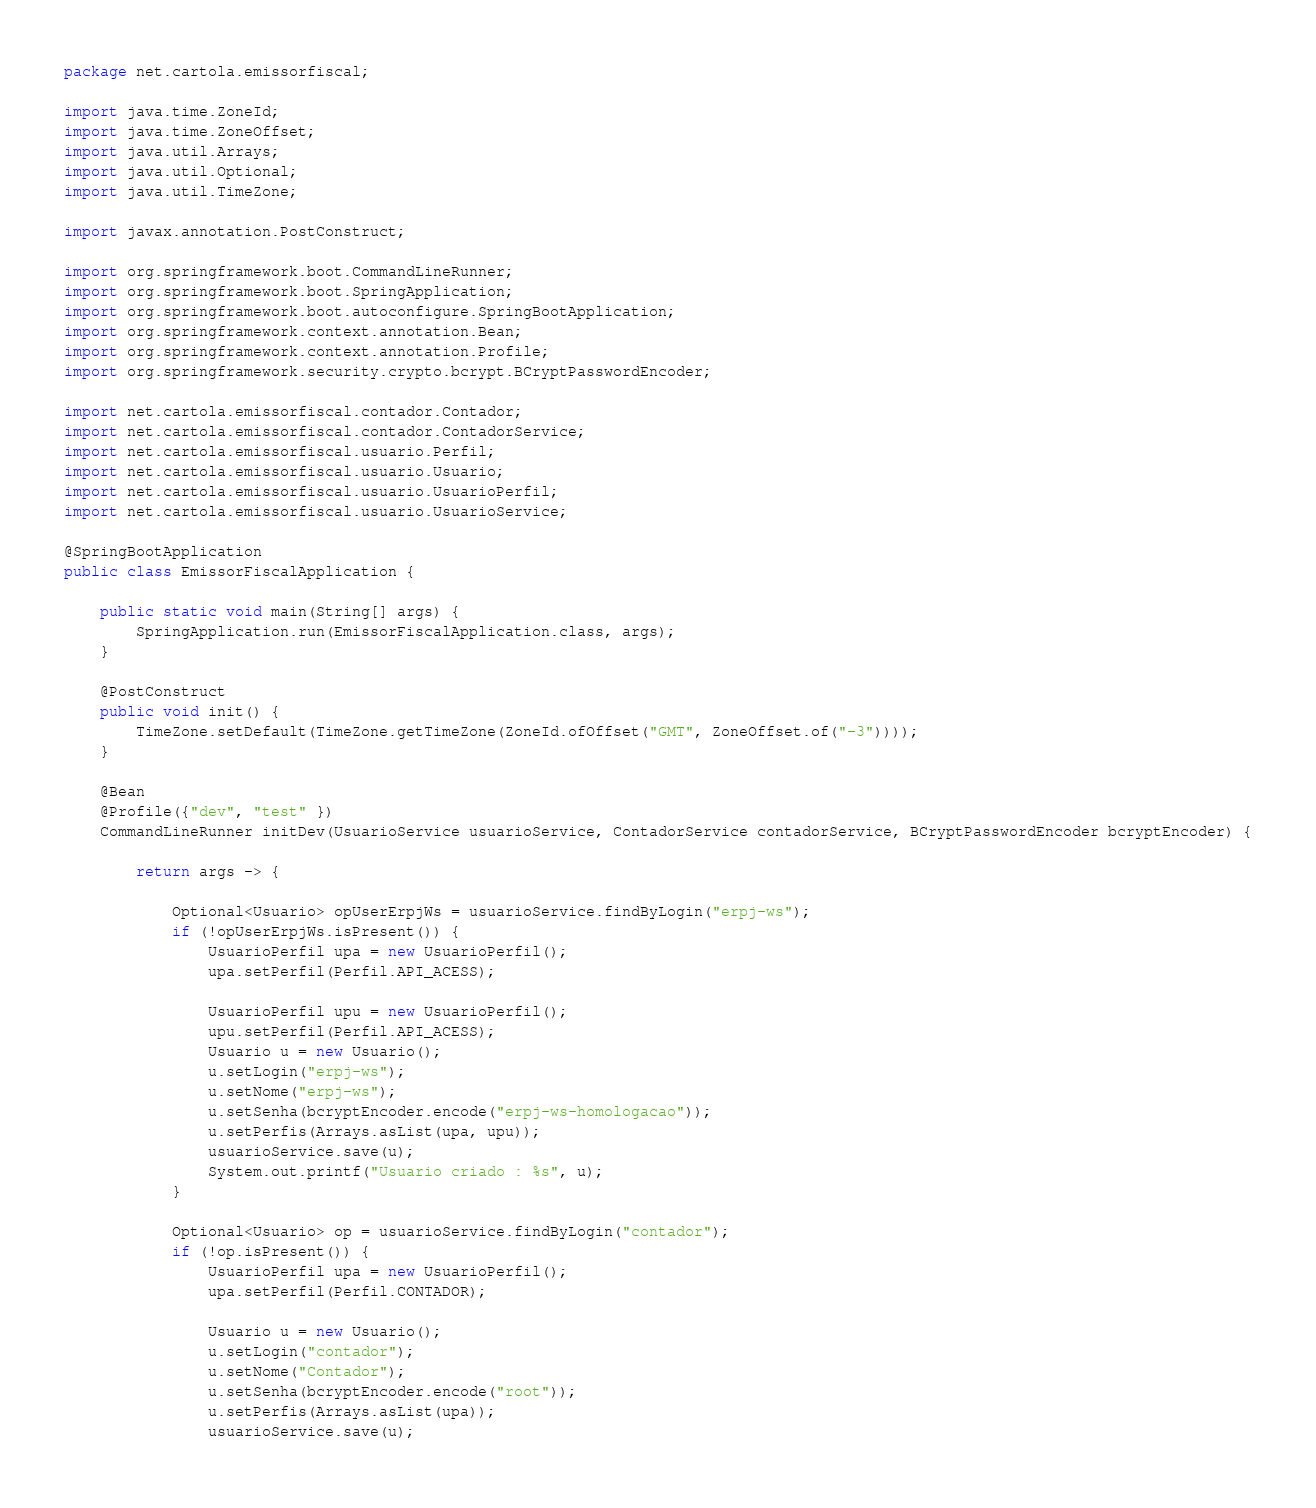Convert code to text. <code><loc_0><loc_0><loc_500><loc_500><_Java_>package net.cartola.emissorfiscal;

import java.time.ZoneId;
import java.time.ZoneOffset;
import java.util.Arrays;
import java.util.Optional;
import java.util.TimeZone;

import javax.annotation.PostConstruct;

import org.springframework.boot.CommandLineRunner;
import org.springframework.boot.SpringApplication;
import org.springframework.boot.autoconfigure.SpringBootApplication;
import org.springframework.context.annotation.Bean;
import org.springframework.context.annotation.Profile;
import org.springframework.security.crypto.bcrypt.BCryptPasswordEncoder;

import net.cartola.emissorfiscal.contador.Contador;
import net.cartola.emissorfiscal.contador.ContadorService;
import net.cartola.emissorfiscal.usuario.Perfil;
import net.cartola.emissorfiscal.usuario.Usuario;
import net.cartola.emissorfiscal.usuario.UsuarioPerfil;
import net.cartola.emissorfiscal.usuario.UsuarioService;

@SpringBootApplication
public class EmissorFiscalApplication {

	public static void main(String[] args) {
		SpringApplication.run(EmissorFiscalApplication.class, args);
	}
	
	@PostConstruct
	public void init() {
		TimeZone.setDefault(TimeZone.getTimeZone(ZoneId.ofOffset("GMT", ZoneOffset.of("-3"))));
	}
	
	@Bean
	@Profile({"dev", "test" })
	CommandLineRunner initDev(UsuarioService usuarioService, ContadorService contadorService, BCryptPasswordEncoder bcryptEncoder) {

		return args -> {
			
			Optional<Usuario> opUserErpjWs = usuarioService.findByLogin("erpj-ws");
			if (!opUserErpjWs.isPresent()) {
				UsuarioPerfil upa = new UsuarioPerfil();
				upa.setPerfil(Perfil.API_ACESS);

				UsuarioPerfil upu = new UsuarioPerfil();
				upu.setPerfil(Perfil.API_ACESS);
				Usuario u = new Usuario();
				u.setLogin("erpj-ws");
				u.setNome("erpj-ws");
				u.setSenha(bcryptEncoder.encode("erpj-ws-homologacao")); 
				u.setPerfis(Arrays.asList(upa, upu)); 
				usuarioService.save(u);
				System.out.printf("Usuario criado : %s", u);
			}
			
			Optional<Usuario> op = usuarioService.findByLogin("contador");
			if (!op.isPresent()) {
				UsuarioPerfil upa = new UsuarioPerfil();
				upa.setPerfil(Perfil.CONTADOR);

				Usuario u = new Usuario();
				u.setLogin("contador");
				u.setNome("Contador");
				u.setSenha(bcryptEncoder.encode("root"));
				u.setPerfis(Arrays.asList(upa));
				usuarioService.save(u);</code> 